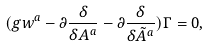<formula> <loc_0><loc_0><loc_500><loc_500>( g w ^ { a } - \partial \frac { \delta } { \delta A ^ { a } } - \partial \frac { \delta } { \delta \tilde { A } ^ { a } } ) \Gamma = 0 ,</formula> 